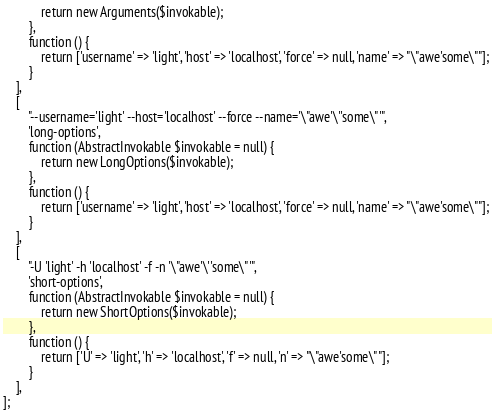Convert code to text. <code><loc_0><loc_0><loc_500><loc_500><_PHP_>            return new Arguments($invokable);
        },
        function () {
            return ['username' => 'light', 'host' => 'localhost', 'force' => null, 'name' => "\"awe'some\""];
        }
    ],
    [
        "--username='light' --host='localhost' --force --name='\"awe'\''some\"'",
        'long-options',
        function (AbstractInvokable $invokable = null) {
            return new LongOptions($invokable);
        },
        function () {
            return ['username' => 'light', 'host' => 'localhost', 'force' => null, 'name' => "\"awe'some\""];
        }
    ],
    [
        "-U 'light' -h 'localhost' -f -n '\"awe'\''some\"'",
        'short-options',
        function (AbstractInvokable $invokable = null) {
            return new ShortOptions($invokable);
        },
        function () {
            return ['U' => 'light', 'h' => 'localhost', 'f' => null, 'n' => "\"awe'some\""];
        }
    ],
];
</code> 